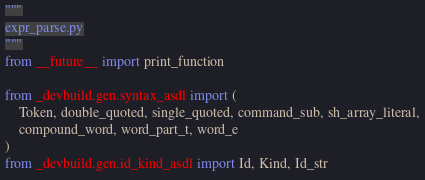Convert code to text. <code><loc_0><loc_0><loc_500><loc_500><_Python_>"""
expr_parse.py
"""
from __future__ import print_function

from _devbuild.gen.syntax_asdl import (
    Token, double_quoted, single_quoted, command_sub, sh_array_literal,
    compound_word, word_part_t, word_e
)
from _devbuild.gen.id_kind_asdl import Id, Kind, Id_str</code> 